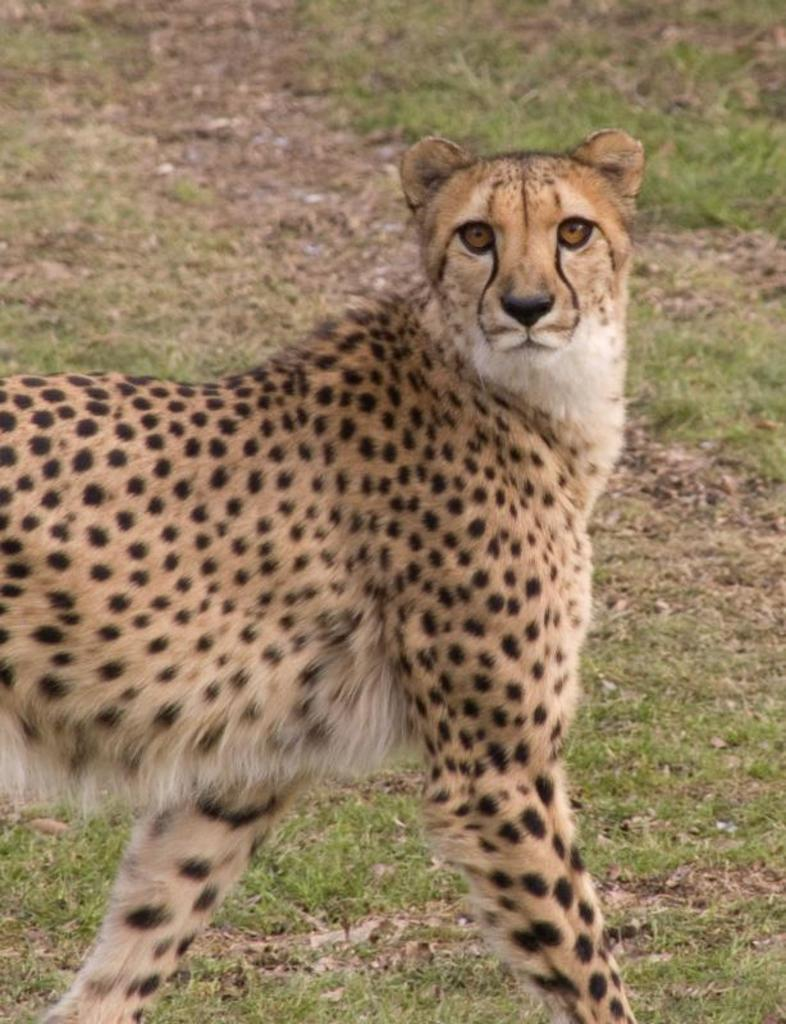What animal is the main subject of the image? There is a leopard in the image. What type of environment is visible in the background of the image? There is grass in the background of the image. What type of credit does the leopard have in the image? There is no mention of credit in the image, as it features a leopard in a grassy environment. 